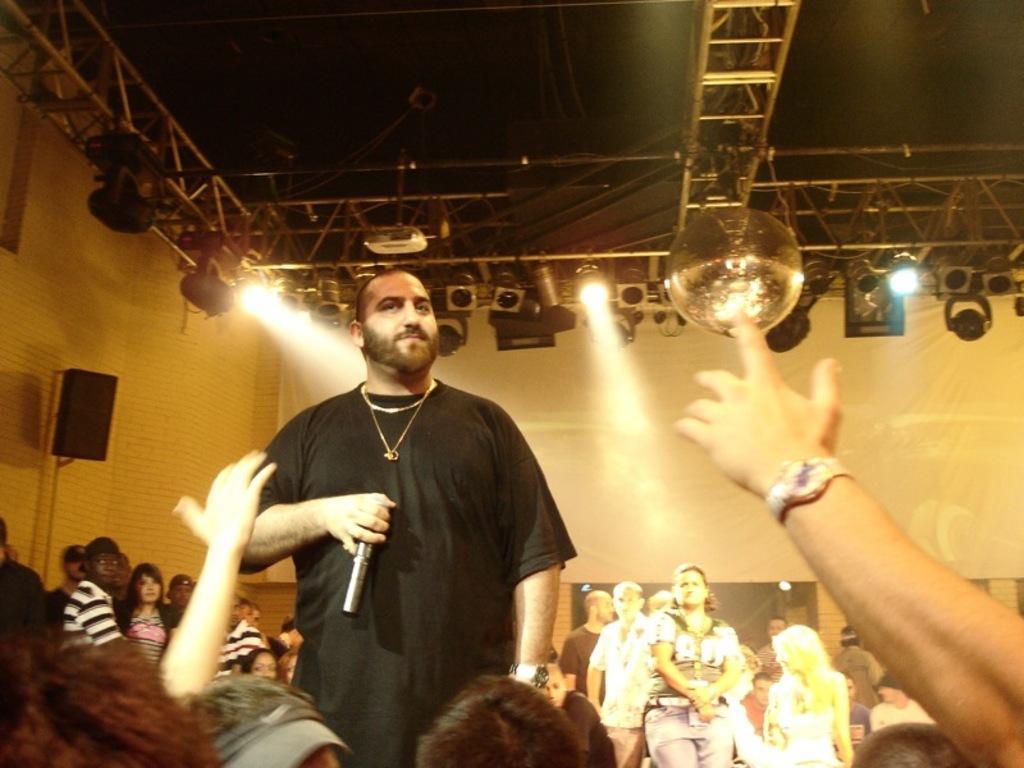Can you describe this image briefly? In the center we can see one man standing and holding microphone. And around him we can see group of persons were standing,they were audience. And coming to back there is a wall and lights. 